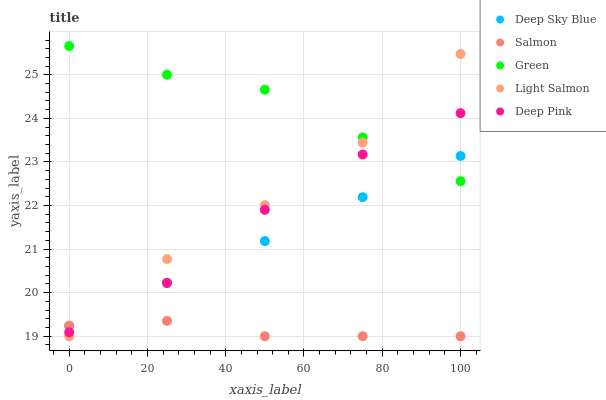Does Salmon have the minimum area under the curve?
Answer yes or no. Yes. Does Green have the maximum area under the curve?
Answer yes or no. Yes. Does Light Salmon have the minimum area under the curve?
Answer yes or no. No. Does Light Salmon have the maximum area under the curve?
Answer yes or no. No. Is Deep Sky Blue the smoothest?
Answer yes or no. Yes. Is Light Salmon the roughest?
Answer yes or no. Yes. Is Deep Pink the smoothest?
Answer yes or no. No. Is Deep Pink the roughest?
Answer yes or no. No. Does Light Salmon have the lowest value?
Answer yes or no. Yes. Does Deep Pink have the lowest value?
Answer yes or no. No. Does Green have the highest value?
Answer yes or no. Yes. Does Light Salmon have the highest value?
Answer yes or no. No. Is Salmon less than Green?
Answer yes or no. Yes. Is Green greater than Salmon?
Answer yes or no. Yes. Does Deep Pink intersect Deep Sky Blue?
Answer yes or no. Yes. Is Deep Pink less than Deep Sky Blue?
Answer yes or no. No. Is Deep Pink greater than Deep Sky Blue?
Answer yes or no. No. Does Salmon intersect Green?
Answer yes or no. No. 